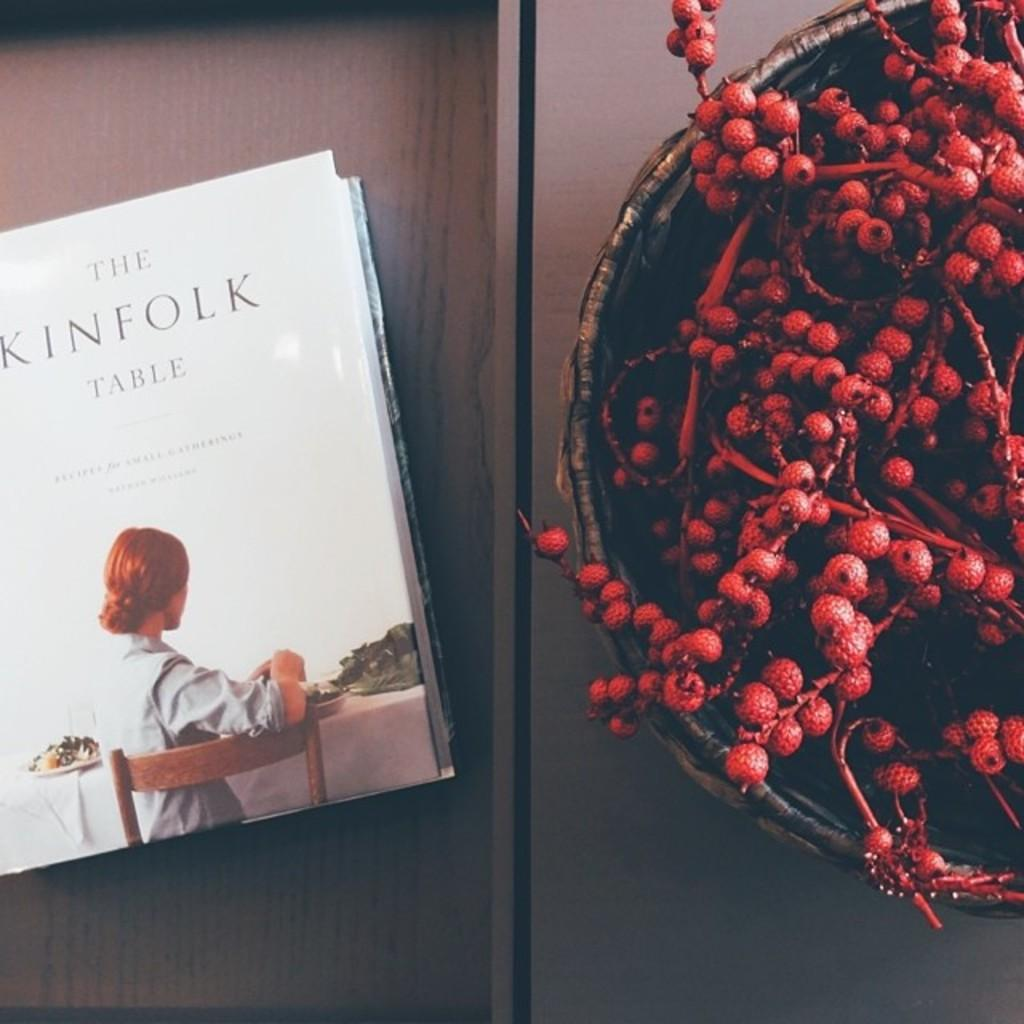<image>
Relay a brief, clear account of the picture shown. Book called the kinfolk table with a bowl of berries next to it 